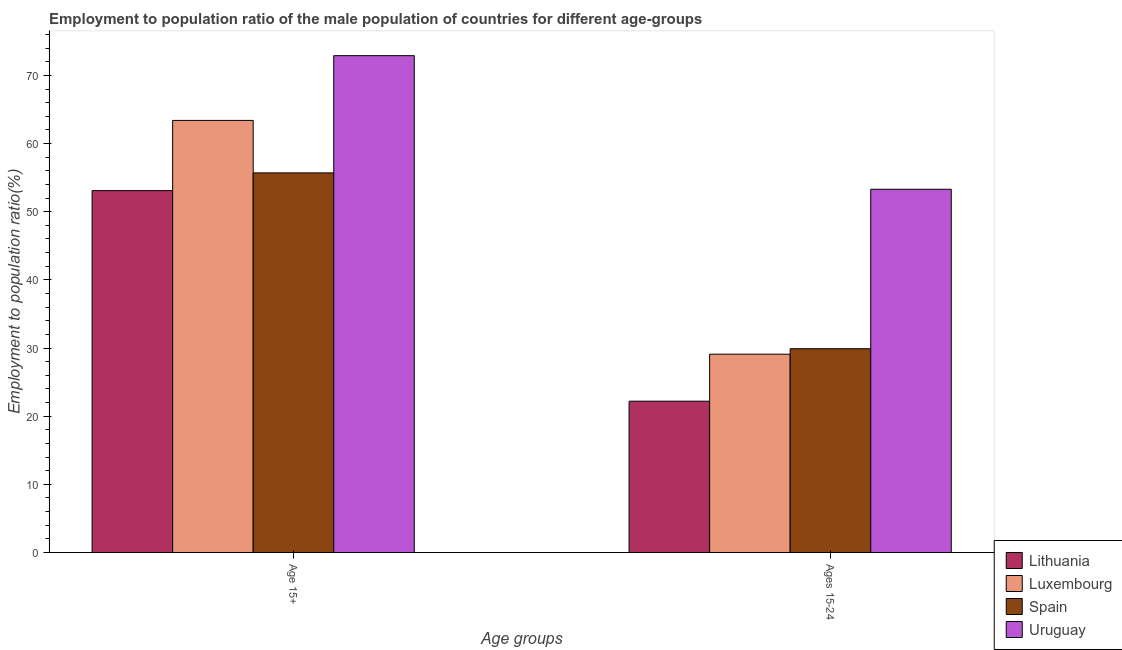How many different coloured bars are there?
Your response must be concise. 4. Are the number of bars per tick equal to the number of legend labels?
Make the answer very short. Yes. Are the number of bars on each tick of the X-axis equal?
Your response must be concise. Yes. How many bars are there on the 2nd tick from the left?
Ensure brevity in your answer.  4. What is the label of the 1st group of bars from the left?
Provide a short and direct response. Age 15+. What is the employment to population ratio(age 15-24) in Uruguay?
Ensure brevity in your answer.  53.3. Across all countries, what is the maximum employment to population ratio(age 15-24)?
Give a very brief answer. 53.3. Across all countries, what is the minimum employment to population ratio(age 15+)?
Offer a terse response. 53.1. In which country was the employment to population ratio(age 15+) maximum?
Your answer should be compact. Uruguay. In which country was the employment to population ratio(age 15+) minimum?
Make the answer very short. Lithuania. What is the total employment to population ratio(age 15+) in the graph?
Your answer should be very brief. 245.1. What is the difference between the employment to population ratio(age 15+) in Lithuania and that in Luxembourg?
Give a very brief answer. -10.3. What is the difference between the employment to population ratio(age 15-24) in Uruguay and the employment to population ratio(age 15+) in Spain?
Ensure brevity in your answer.  -2.4. What is the average employment to population ratio(age 15-24) per country?
Your answer should be very brief. 33.62. What is the difference between the employment to population ratio(age 15+) and employment to population ratio(age 15-24) in Luxembourg?
Your answer should be compact. 34.3. What is the ratio of the employment to population ratio(age 15+) in Lithuania to that in Uruguay?
Your response must be concise. 0.73. Is the employment to population ratio(age 15-24) in Spain less than that in Luxembourg?
Offer a very short reply. No. In how many countries, is the employment to population ratio(age 15-24) greater than the average employment to population ratio(age 15-24) taken over all countries?
Your answer should be very brief. 1. What does the 2nd bar from the left in Ages 15-24 represents?
Give a very brief answer. Luxembourg. How many bars are there?
Offer a terse response. 8. Are all the bars in the graph horizontal?
Provide a succinct answer. No. What is the difference between two consecutive major ticks on the Y-axis?
Your answer should be compact. 10. Does the graph contain any zero values?
Ensure brevity in your answer.  No. Where does the legend appear in the graph?
Give a very brief answer. Bottom right. How are the legend labels stacked?
Keep it short and to the point. Vertical. What is the title of the graph?
Offer a terse response. Employment to population ratio of the male population of countries for different age-groups. Does "Israel" appear as one of the legend labels in the graph?
Provide a short and direct response. No. What is the label or title of the X-axis?
Your answer should be compact. Age groups. What is the label or title of the Y-axis?
Make the answer very short. Employment to population ratio(%). What is the Employment to population ratio(%) in Lithuania in Age 15+?
Your answer should be compact. 53.1. What is the Employment to population ratio(%) in Luxembourg in Age 15+?
Your response must be concise. 63.4. What is the Employment to population ratio(%) of Spain in Age 15+?
Ensure brevity in your answer.  55.7. What is the Employment to population ratio(%) of Uruguay in Age 15+?
Your answer should be compact. 72.9. What is the Employment to population ratio(%) of Lithuania in Ages 15-24?
Give a very brief answer. 22.2. What is the Employment to population ratio(%) of Luxembourg in Ages 15-24?
Offer a very short reply. 29.1. What is the Employment to population ratio(%) of Spain in Ages 15-24?
Ensure brevity in your answer.  29.9. What is the Employment to population ratio(%) in Uruguay in Ages 15-24?
Make the answer very short. 53.3. Across all Age groups, what is the maximum Employment to population ratio(%) of Lithuania?
Provide a succinct answer. 53.1. Across all Age groups, what is the maximum Employment to population ratio(%) of Luxembourg?
Your response must be concise. 63.4. Across all Age groups, what is the maximum Employment to population ratio(%) of Spain?
Your answer should be very brief. 55.7. Across all Age groups, what is the maximum Employment to population ratio(%) in Uruguay?
Offer a terse response. 72.9. Across all Age groups, what is the minimum Employment to population ratio(%) of Lithuania?
Make the answer very short. 22.2. Across all Age groups, what is the minimum Employment to population ratio(%) of Luxembourg?
Provide a succinct answer. 29.1. Across all Age groups, what is the minimum Employment to population ratio(%) of Spain?
Your answer should be compact. 29.9. Across all Age groups, what is the minimum Employment to population ratio(%) of Uruguay?
Provide a succinct answer. 53.3. What is the total Employment to population ratio(%) of Lithuania in the graph?
Your answer should be very brief. 75.3. What is the total Employment to population ratio(%) of Luxembourg in the graph?
Your response must be concise. 92.5. What is the total Employment to population ratio(%) in Spain in the graph?
Offer a terse response. 85.6. What is the total Employment to population ratio(%) in Uruguay in the graph?
Your answer should be very brief. 126.2. What is the difference between the Employment to population ratio(%) of Lithuania in Age 15+ and that in Ages 15-24?
Keep it short and to the point. 30.9. What is the difference between the Employment to population ratio(%) of Luxembourg in Age 15+ and that in Ages 15-24?
Give a very brief answer. 34.3. What is the difference between the Employment to population ratio(%) in Spain in Age 15+ and that in Ages 15-24?
Provide a short and direct response. 25.8. What is the difference between the Employment to population ratio(%) of Uruguay in Age 15+ and that in Ages 15-24?
Offer a terse response. 19.6. What is the difference between the Employment to population ratio(%) in Lithuania in Age 15+ and the Employment to population ratio(%) in Luxembourg in Ages 15-24?
Ensure brevity in your answer.  24. What is the difference between the Employment to population ratio(%) of Lithuania in Age 15+ and the Employment to population ratio(%) of Spain in Ages 15-24?
Provide a short and direct response. 23.2. What is the difference between the Employment to population ratio(%) of Luxembourg in Age 15+ and the Employment to population ratio(%) of Spain in Ages 15-24?
Your answer should be compact. 33.5. What is the difference between the Employment to population ratio(%) in Spain in Age 15+ and the Employment to population ratio(%) in Uruguay in Ages 15-24?
Ensure brevity in your answer.  2.4. What is the average Employment to population ratio(%) of Lithuania per Age groups?
Offer a very short reply. 37.65. What is the average Employment to population ratio(%) of Luxembourg per Age groups?
Ensure brevity in your answer.  46.25. What is the average Employment to population ratio(%) of Spain per Age groups?
Provide a succinct answer. 42.8. What is the average Employment to population ratio(%) in Uruguay per Age groups?
Make the answer very short. 63.1. What is the difference between the Employment to population ratio(%) of Lithuania and Employment to population ratio(%) of Spain in Age 15+?
Provide a short and direct response. -2.6. What is the difference between the Employment to population ratio(%) in Lithuania and Employment to population ratio(%) in Uruguay in Age 15+?
Provide a succinct answer. -19.8. What is the difference between the Employment to population ratio(%) in Spain and Employment to population ratio(%) in Uruguay in Age 15+?
Your answer should be very brief. -17.2. What is the difference between the Employment to population ratio(%) of Lithuania and Employment to population ratio(%) of Luxembourg in Ages 15-24?
Make the answer very short. -6.9. What is the difference between the Employment to population ratio(%) in Lithuania and Employment to population ratio(%) in Spain in Ages 15-24?
Offer a very short reply. -7.7. What is the difference between the Employment to population ratio(%) in Lithuania and Employment to population ratio(%) in Uruguay in Ages 15-24?
Your answer should be very brief. -31.1. What is the difference between the Employment to population ratio(%) of Luxembourg and Employment to population ratio(%) of Spain in Ages 15-24?
Make the answer very short. -0.8. What is the difference between the Employment to population ratio(%) of Luxembourg and Employment to population ratio(%) of Uruguay in Ages 15-24?
Offer a terse response. -24.2. What is the difference between the Employment to population ratio(%) of Spain and Employment to population ratio(%) of Uruguay in Ages 15-24?
Offer a very short reply. -23.4. What is the ratio of the Employment to population ratio(%) of Lithuania in Age 15+ to that in Ages 15-24?
Provide a succinct answer. 2.39. What is the ratio of the Employment to population ratio(%) of Luxembourg in Age 15+ to that in Ages 15-24?
Provide a succinct answer. 2.18. What is the ratio of the Employment to population ratio(%) of Spain in Age 15+ to that in Ages 15-24?
Provide a succinct answer. 1.86. What is the ratio of the Employment to population ratio(%) in Uruguay in Age 15+ to that in Ages 15-24?
Provide a short and direct response. 1.37. What is the difference between the highest and the second highest Employment to population ratio(%) in Lithuania?
Make the answer very short. 30.9. What is the difference between the highest and the second highest Employment to population ratio(%) in Luxembourg?
Provide a succinct answer. 34.3. What is the difference between the highest and the second highest Employment to population ratio(%) in Spain?
Provide a short and direct response. 25.8. What is the difference between the highest and the second highest Employment to population ratio(%) of Uruguay?
Make the answer very short. 19.6. What is the difference between the highest and the lowest Employment to population ratio(%) of Lithuania?
Your response must be concise. 30.9. What is the difference between the highest and the lowest Employment to population ratio(%) in Luxembourg?
Provide a succinct answer. 34.3. What is the difference between the highest and the lowest Employment to population ratio(%) of Spain?
Ensure brevity in your answer.  25.8. What is the difference between the highest and the lowest Employment to population ratio(%) in Uruguay?
Ensure brevity in your answer.  19.6. 